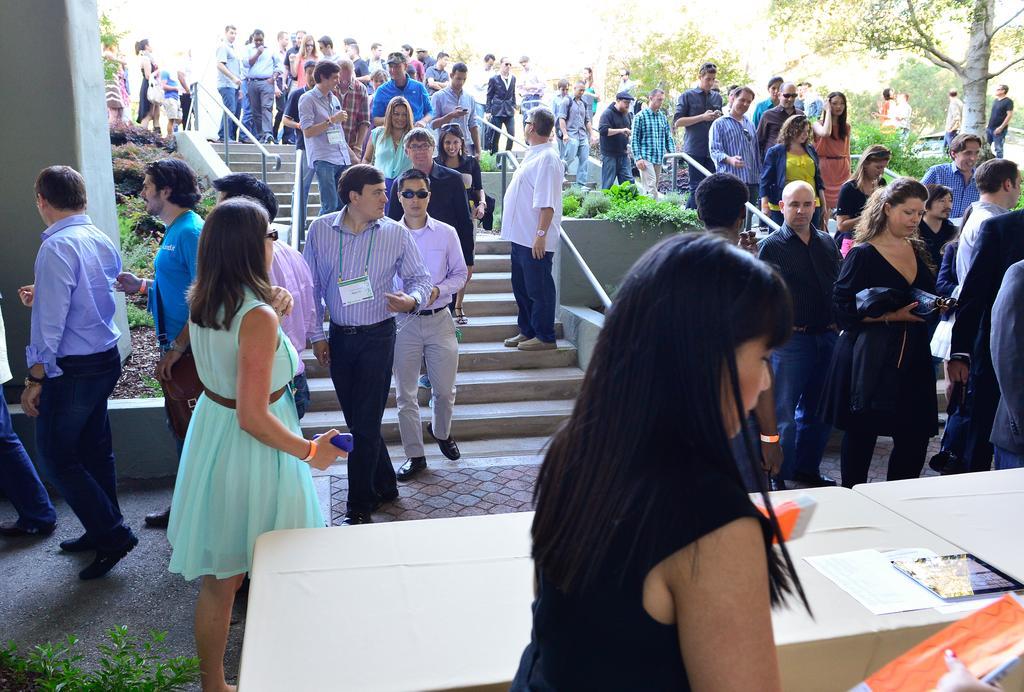How would you summarize this image in a sentence or two? There is a woman in black color dress holding an object with one hand near white color table on which, there are documents and other object. In the background, there are persons, some of them are walking on the steps, there are plants, trees and there is wall. 